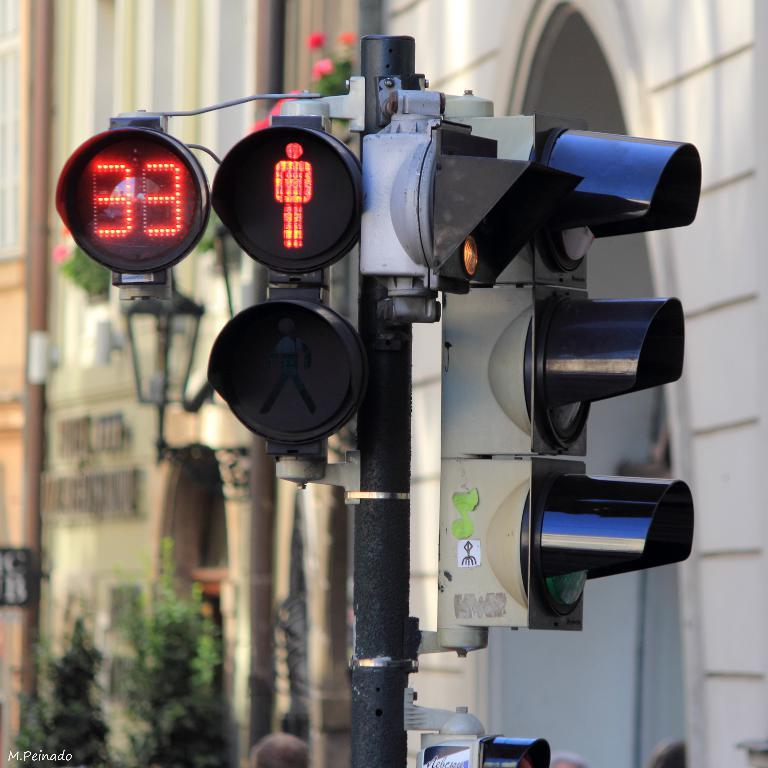What is the main object in the image? There is a traffic light on a pole in the image. What is the background of the image? There is a part of a building wall visible behind the traffic light. Are there any other elements in the image besides the traffic light and building wall? Yes, there are plants near the building wall. What type of love can be seen between the traffic light and the building wall in the image? There is no love depicted between the traffic light and the building wall in the image, as they are inanimate objects. 